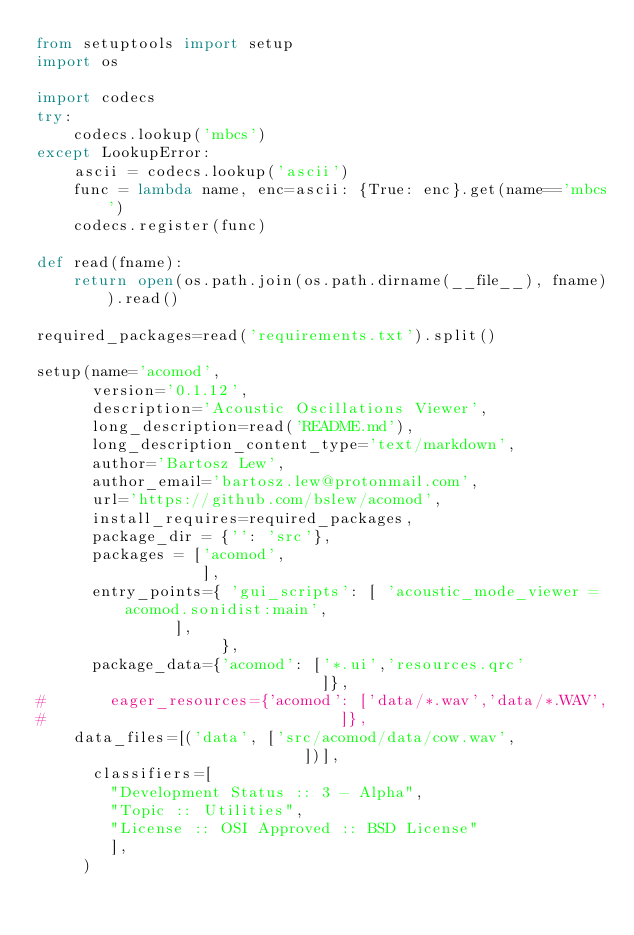<code> <loc_0><loc_0><loc_500><loc_500><_Python_>from setuptools import setup
import os

import codecs
try:
    codecs.lookup('mbcs')
except LookupError:
    ascii = codecs.lookup('ascii')
    func = lambda name, enc=ascii: {True: enc}.get(name=='mbcs')
    codecs.register(func)
    
def read(fname):
    return open(os.path.join(os.path.dirname(__file__), fname)).read()

required_packages=read('requirements.txt').split()

setup(name='acomod',
      version='0.1.12',
      description='Acoustic Oscillations Viewer',
      long_description=read('README.md'),
      long_description_content_type='text/markdown',
      author='Bartosz Lew',
      author_email='bartosz.lew@protonmail.com',
      url='https://github.com/bslew/acomod',
      install_requires=required_packages,
      package_dir = {'': 'src'},
      packages = ['acomod',
                  ],
      entry_points={ 'gui_scripts': [ 'acoustic_mode_viewer = acomod.sonidist:main',
               ],
                    },
      package_data={'acomod': ['*.ui','resources.qrc'
                               ]},
#       eager_resources={'acomod': ['data/*.wav','data/*.WAV',
#                                ]},
    data_files=[('data', ['src/acomod/data/cow.wav',
                             ])],
      classifiers=[
        "Development Status :: 3 - Alpha",
        "Topic :: Utilities",
        "License :: OSI Approved :: BSD License"
        ],
     )
</code> 